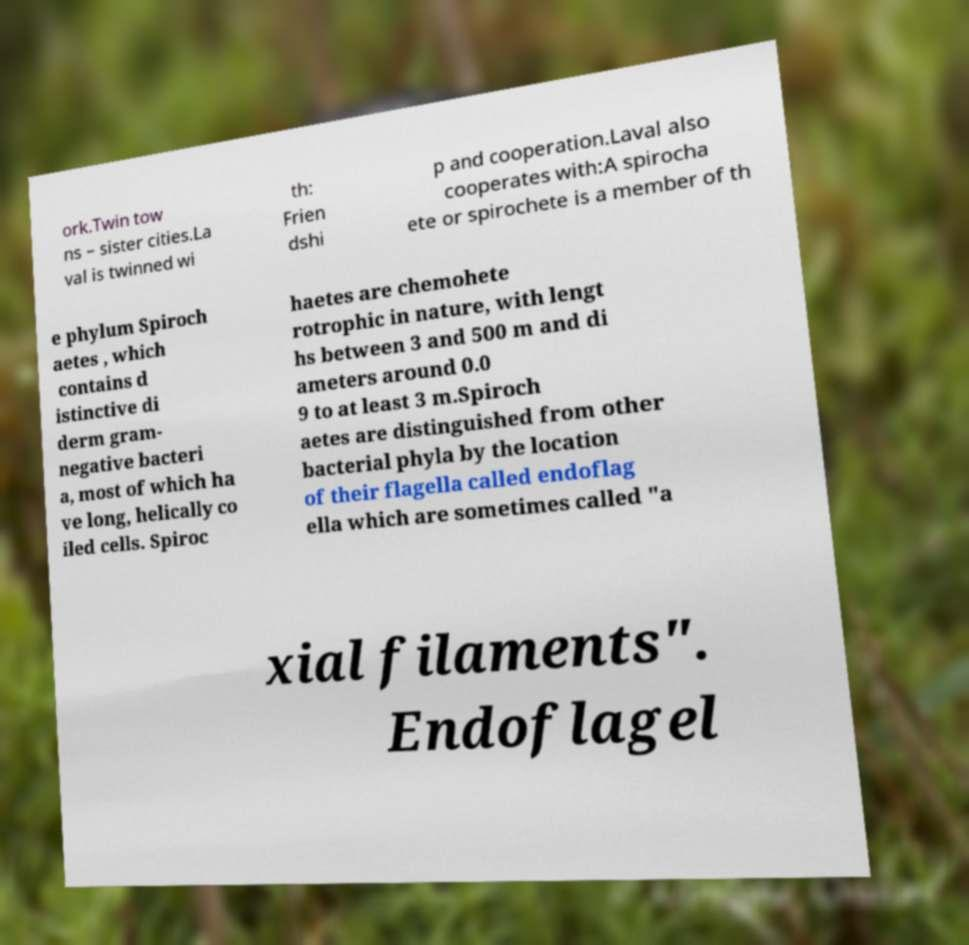Can you read and provide the text displayed in the image?This photo seems to have some interesting text. Can you extract and type it out for me? ork.Twin tow ns – sister cities.La val is twinned wi th: Frien dshi p and cooperation.Laval also cooperates with:A spirocha ete or spirochete is a member of th e phylum Spiroch aetes , which contains d istinctive di derm gram- negative bacteri a, most of which ha ve long, helically co iled cells. Spiroc haetes are chemohete rotrophic in nature, with lengt hs between 3 and 500 m and di ameters around 0.0 9 to at least 3 m.Spiroch aetes are distinguished from other bacterial phyla by the location of their flagella called endoflag ella which are sometimes called "a xial filaments". Endoflagel 